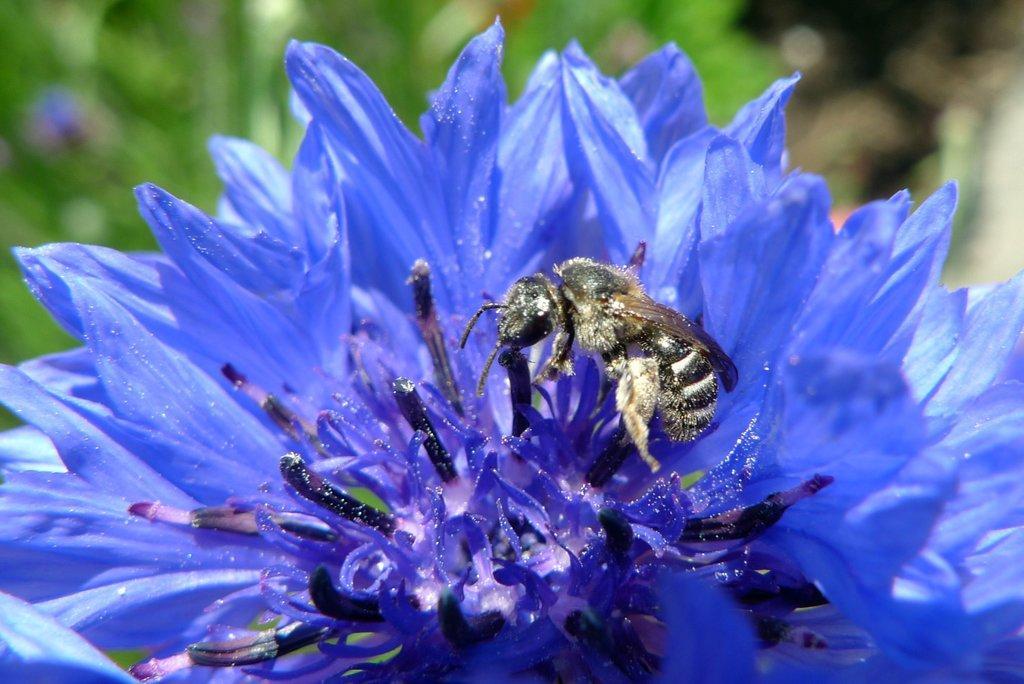In one or two sentences, can you explain what this image depicts? In this picture there is a purple color flower on which honey bee is sitting. Behind there is a green blur background. 